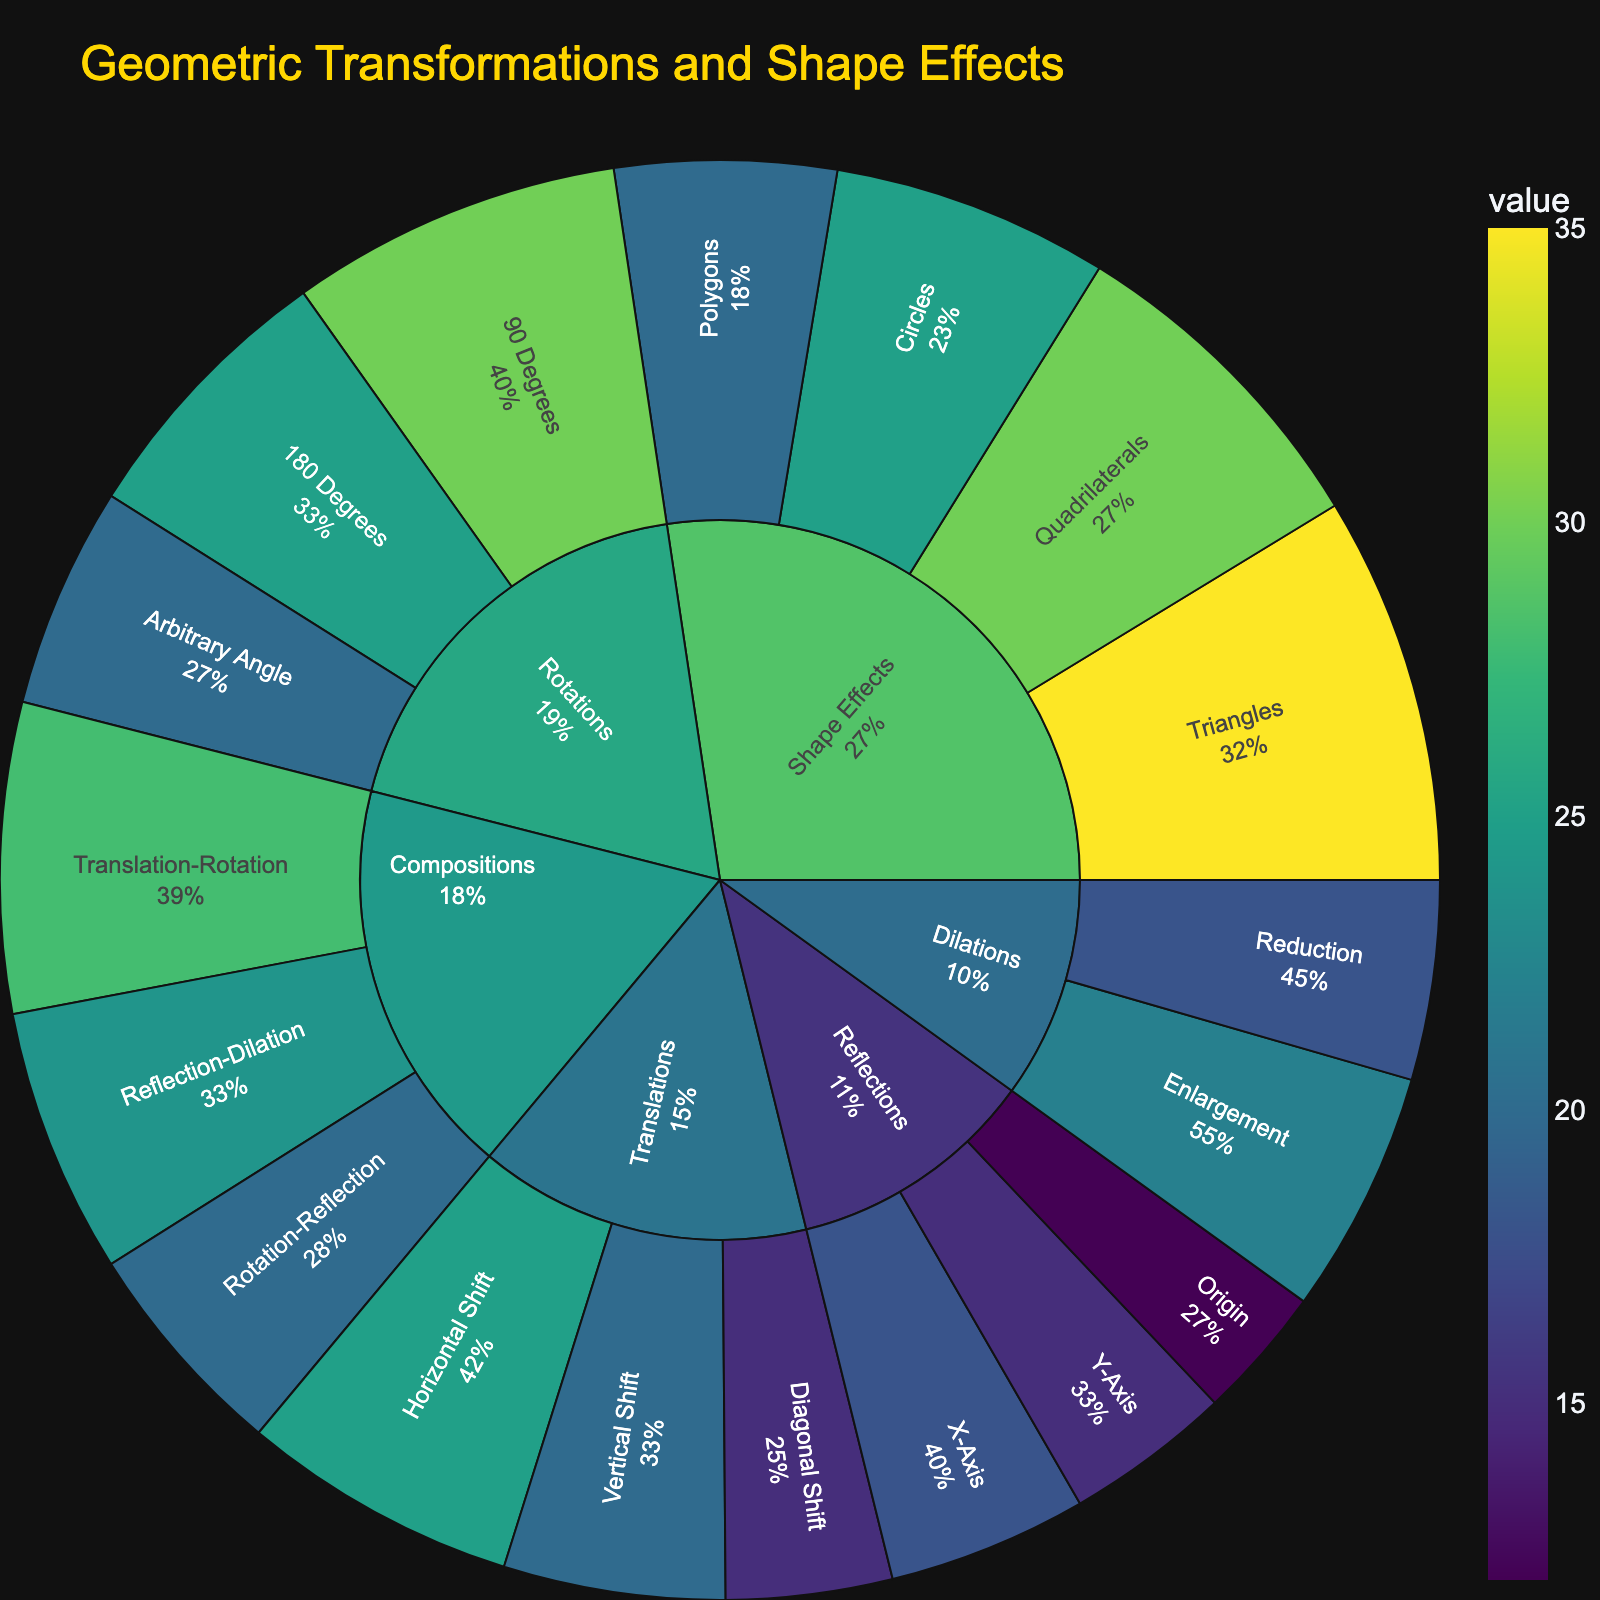What's the title of the plot? The title is displayed at the top of the plot. Look for the largest text element at the top of the figure.
Answer: Geometric Transformations and Shape Effects Which subcategory under Translations has the highest value? Under the Translations category, identify the segment with the highest percentage value.
Answer: Horizontal Shift How many subcategories are there under the Rotations category? Count each colored segment under the Rotations category displayed in the plot.
Answer: 3 What is the value of the Reflection on the Y-Axis? Locate the Reflection category, then find the Y-Axis subcategory. Read the value associated with it.
Answer: 15 What is the sum of the values for all the subcategories under Dilations? Add the values of the Enlargements and Reductions subcategories together: 22 + 18 = 40.
Answer: 40 Which category has more subcategories: Compositions or Shape Effects? Count the number of subcategories under each category. Compositions have 3, and Shape Effects have 4.
Answer: Shape Effects Which subcategory has the lowest value in the entire plot? Identify the subcategory with the smallest segment and the lowest value displayed in the entire figure.
Answer: Reflection at Origin Compare the value of 90 Degrees Rotation with Arbitrary Angle Rotation. Which is greater? Compare the values given for the two subcategories under Rotations. 90 Degrees has 30, and Arbitrary Angle has 20.
Answer: 90 Degrees What is the percentage value of Vertical Shift under Translations relative to the entire plot’s total value? First, sum all the values in the plot, then calculate the percentage of Vertical Shift (20) over the total sum (315): (20/315) * 100 ≈ 6.35%.
Answer: 6.35% What is the combined value of the subcategories under Compositions? Add the values of all subcategories under Compositions: 28 + 24 + 20 = 72.
Answer: 72 